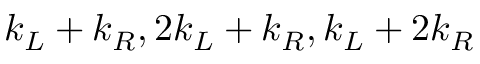<formula> <loc_0><loc_0><loc_500><loc_500>k _ { L } + k _ { R } , 2 k _ { L } + k _ { R } , k _ { L } + 2 k _ { R }</formula> 